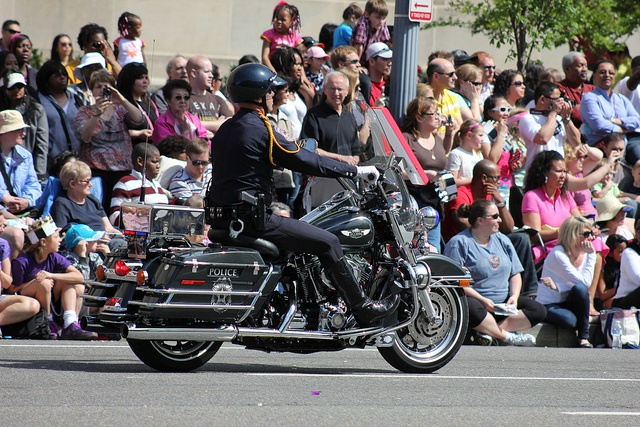Describe the objects in this image and their specific colors. I can see people in darkgray, black, gray, and lightgray tones, motorcycle in darkgray, black, gray, and lightgray tones, people in darkgray, black, and gray tones, people in darkgray, black, gray, and lightgray tones, and people in darkgray, black, gray, maroon, and purple tones in this image. 